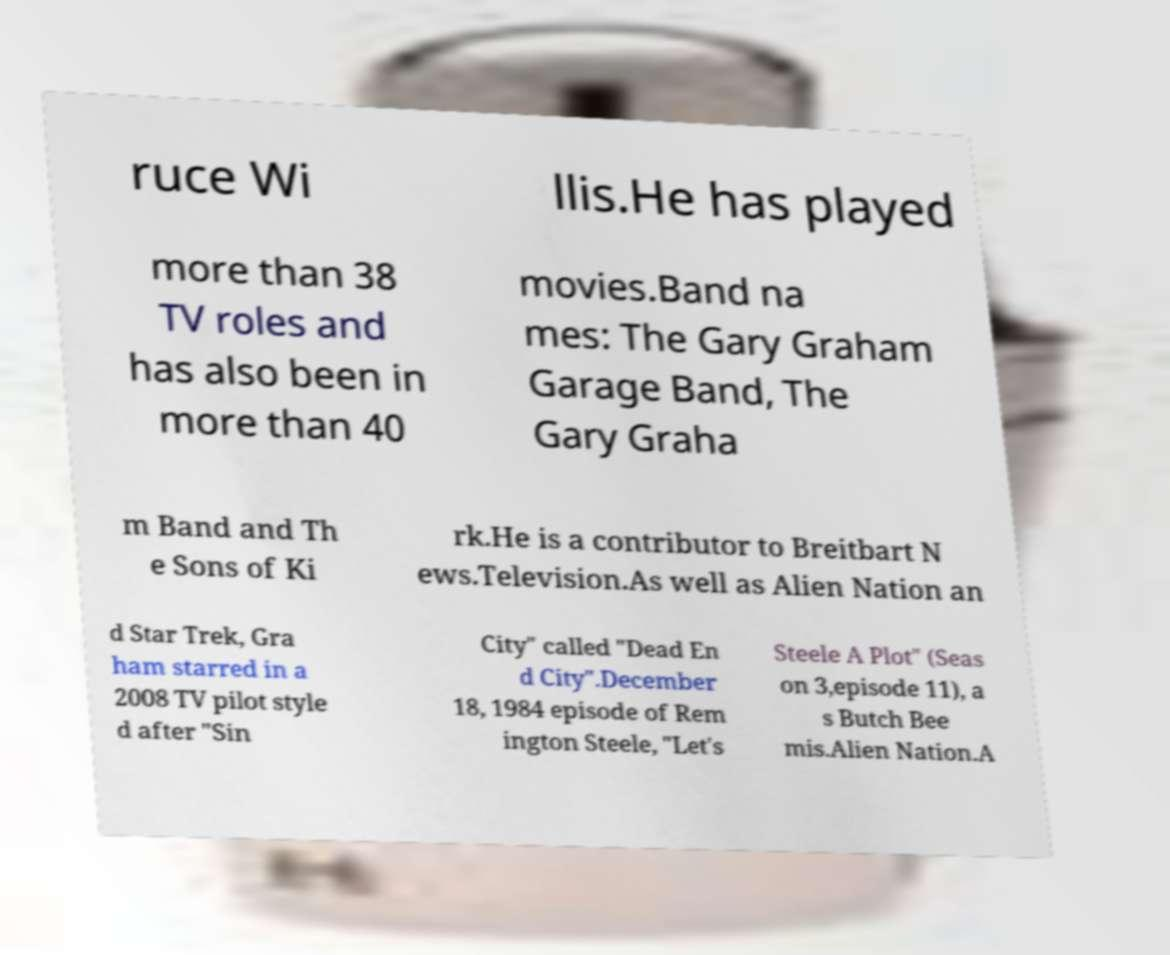What messages or text are displayed in this image? I need them in a readable, typed format. ruce Wi llis.He has played more than 38 TV roles and has also been in more than 40 movies.Band na mes: The Gary Graham Garage Band, The Gary Graha m Band and Th e Sons of Ki rk.He is a contributor to Breitbart N ews.Television.As well as Alien Nation an d Star Trek, Gra ham starred in a 2008 TV pilot style d after "Sin City" called "Dead En d City".December 18, 1984 episode of Rem ington Steele, "Let's Steele A Plot" (Seas on 3,episode 11), a s Butch Bee mis.Alien Nation.A 